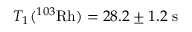Convert formula to latex. <formula><loc_0><loc_0><loc_500><loc_500>T _ { 1 } ( ^ { 1 0 3 } R h ) = 2 8 . 2 \pm 1 . 2 \ s</formula> 